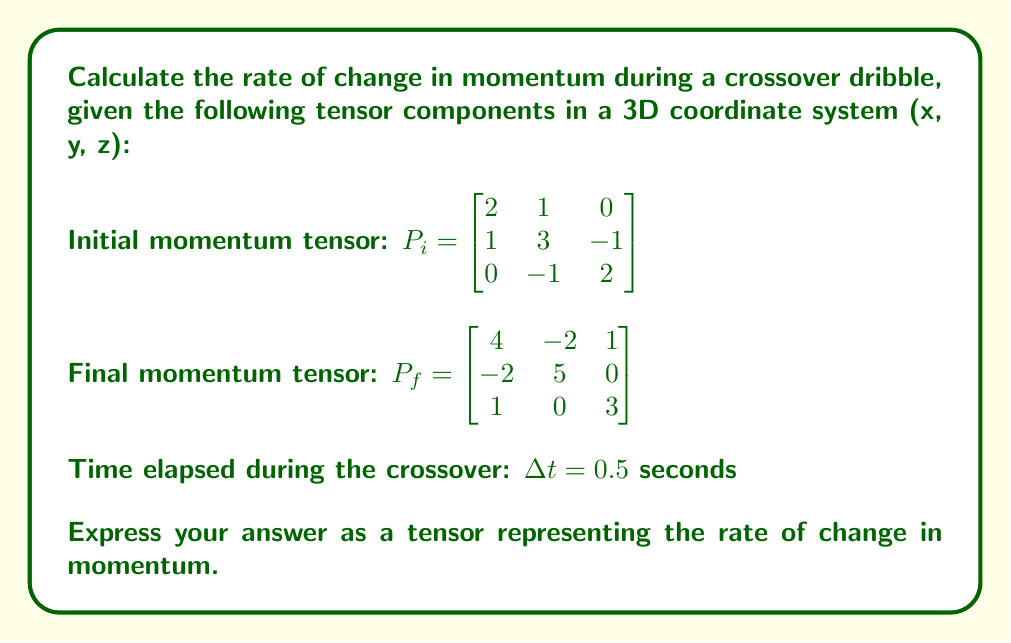Can you solve this math problem? To solve this problem, we'll follow these steps:

1) First, we need to calculate the change in momentum tensor:
   $$\Delta P = P_f - P_i$$

   $\Delta P = \begin{bmatrix} 4 & -2 & 1 \\ -2 & 5 & 0 \\ 1 & 0 & 3 \end{bmatrix} - \begin{bmatrix} 2 & 1 & 0 \\ 1 & 3 & -1 \\ 0 & -1 & 2 \end{bmatrix}$

   $\Delta P = \begin{bmatrix} 2 & -3 & 1 \\ -3 & 2 & 1 \\ 1 & 1 & 1 \end{bmatrix}$

2) The rate of change in momentum is given by the time derivative of momentum:
   $$\frac{dP}{dt} = \lim_{\Delta t \to 0} \frac{\Delta P}{\Delta t}$$

3) Since we have a finite time interval, we can approximate this as:
   $$\frac{\Delta P}{\Delta t} = \frac{1}{\Delta t} \begin{bmatrix} 2 & -3 & 1 \\ -3 & 2 & 1 \\ 1 & 1 & 1 \end{bmatrix}$$

4) Substituting $\Delta t = 0.5$ seconds:
   $$\frac{\Delta P}{\Delta t} = \frac{1}{0.5} \begin{bmatrix} 2 & -3 & 1 \\ -3 & 2 & 1 \\ 1 & 1 & 1 \end{bmatrix} = 2 \begin{bmatrix} 2 & -3 & 1 \\ -3 & 2 & 1 \\ 1 & 1 & 1 \end{bmatrix}$$

5) Simplifying:
   $$\frac{\Delta P}{\Delta t} = \begin{bmatrix} 4 & -6 & 2 \\ -6 & 4 & 2 \\ 2 & 2 & 2 \end{bmatrix}$$

This tensor represents the rate of change in momentum during the crossover dribble.
Answer: $\frac{\Delta P}{\Delta t} = \begin{bmatrix} 4 & -6 & 2 \\ -6 & 4 & 2 \\ 2 & 2 & 2 \end{bmatrix}$ 